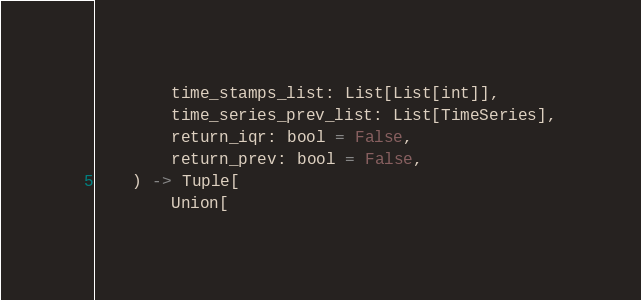Convert code to text. <code><loc_0><loc_0><loc_500><loc_500><_Python_>        time_stamps_list: List[List[int]],
        time_series_prev_list: List[TimeSeries],
        return_iqr: bool = False,
        return_prev: bool = False,
    ) -> Tuple[
        Union[</code> 